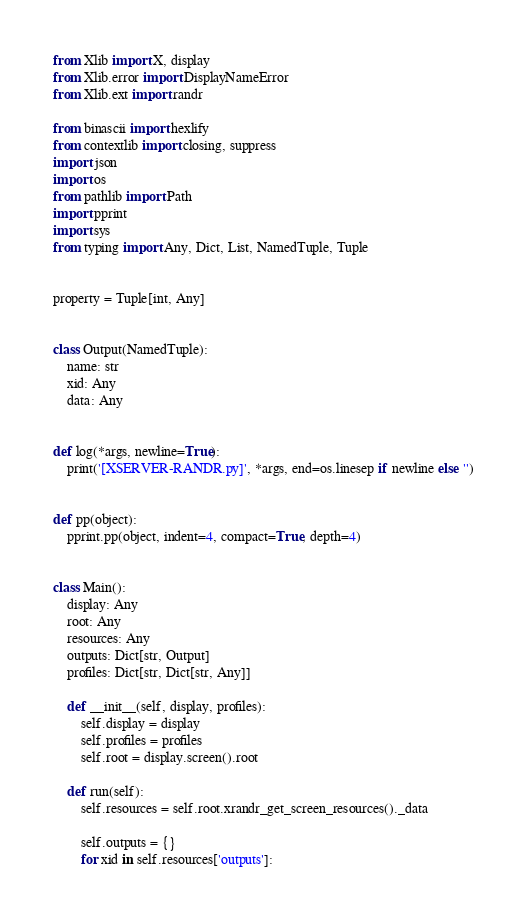Convert code to text. <code><loc_0><loc_0><loc_500><loc_500><_Python_>from Xlib import X, display
from Xlib.error import DisplayNameError
from Xlib.ext import randr

from binascii import hexlify
from contextlib import closing, suppress
import json
import os
from pathlib import Path
import pprint
import sys
from typing import Any, Dict, List, NamedTuple, Tuple


property = Tuple[int, Any]


class Output(NamedTuple):
    name: str
    xid: Any
    data: Any


def log(*args, newline=True):
    print('[XSERVER-RANDR.py]', *args, end=os.linesep if newline else '')


def pp(object):
    pprint.pp(object, indent=4, compact=True, depth=4)


class Main():
    display: Any
    root: Any
    resources: Any
    outputs: Dict[str, Output]
    profiles: Dict[str, Dict[str, Any]]

    def __init__(self, display, profiles):
        self.display = display
        self.profiles = profiles
        self.root = display.screen().root

    def run(self):
        self.resources = self.root.xrandr_get_screen_resources()._data

        self.outputs = {}
        for xid in self.resources['outputs']:</code> 